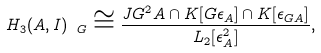Convert formula to latex. <formula><loc_0><loc_0><loc_500><loc_500>H _ { 3 } ( A , I ) _ { \ G } \cong \frac { J G ^ { 2 } A \cap K [ G \epsilon _ { A } ] \cap K [ \epsilon _ { G A } ] } { L _ { 2 } [ \epsilon _ { A } ^ { 2 } ] } ,</formula> 